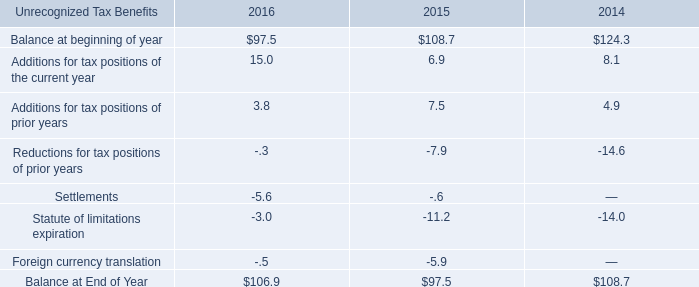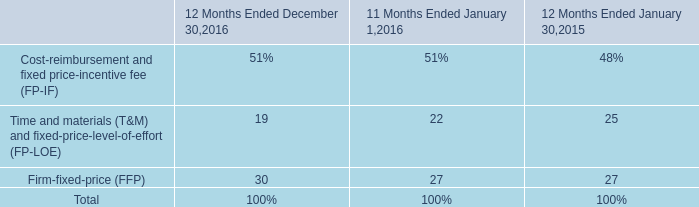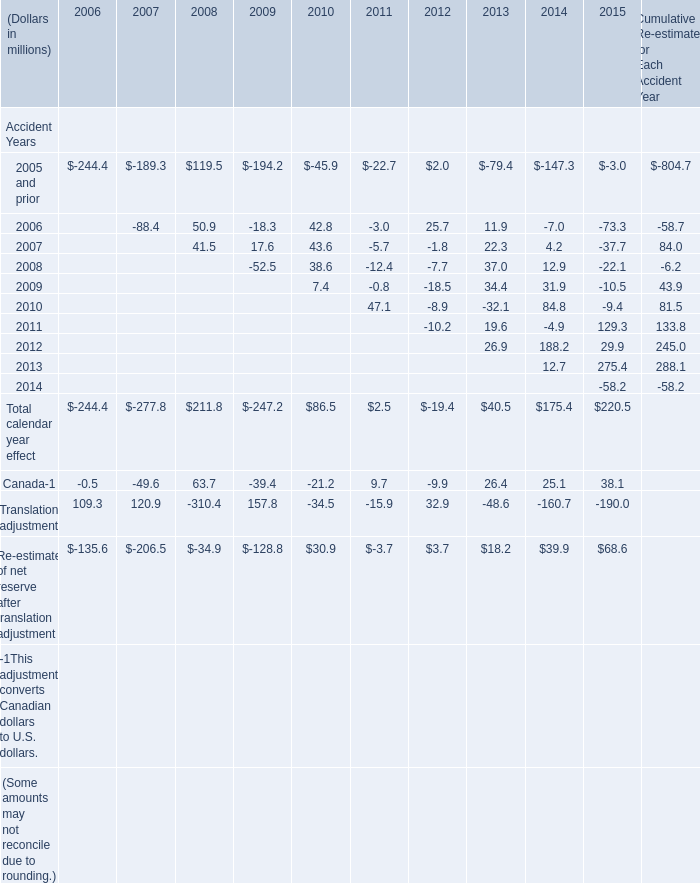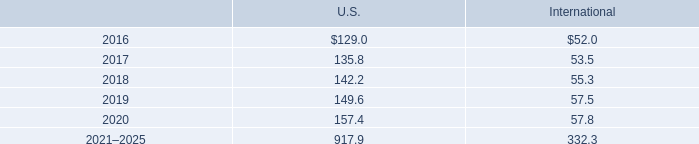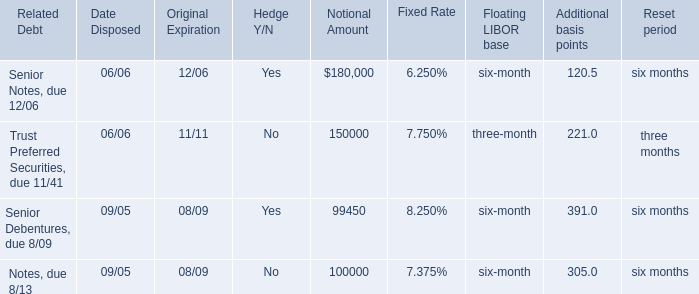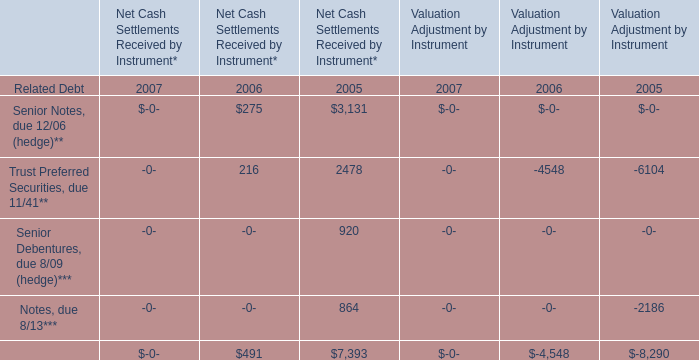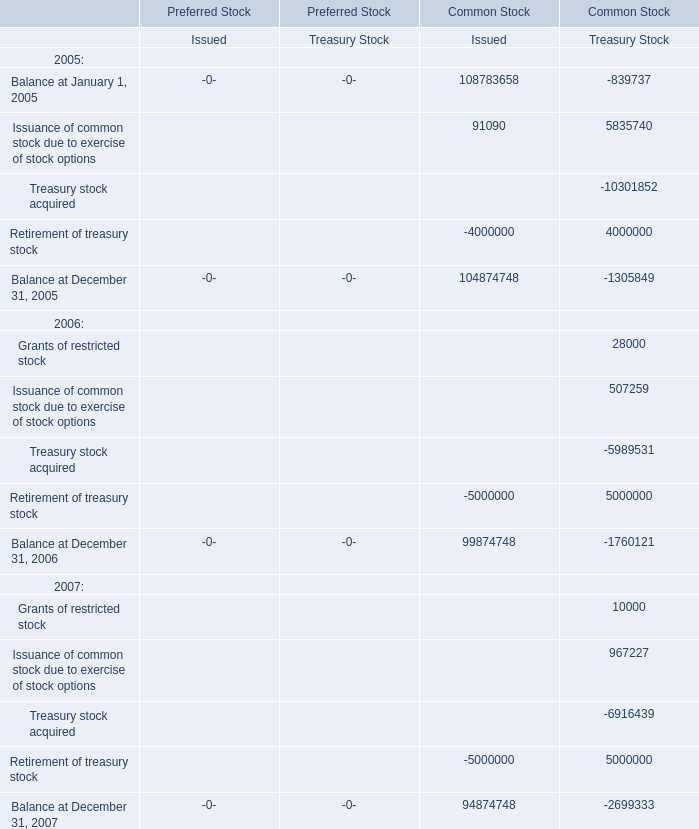what's the total amount of Notes, due 8/13*** of Valuation Adjustment by Instrument 2005, and Treasury stock acquired of Common Stock Treasury Stock ? 
Computations: (2186.0 + 10301852.0)
Answer: 10304038.0. 